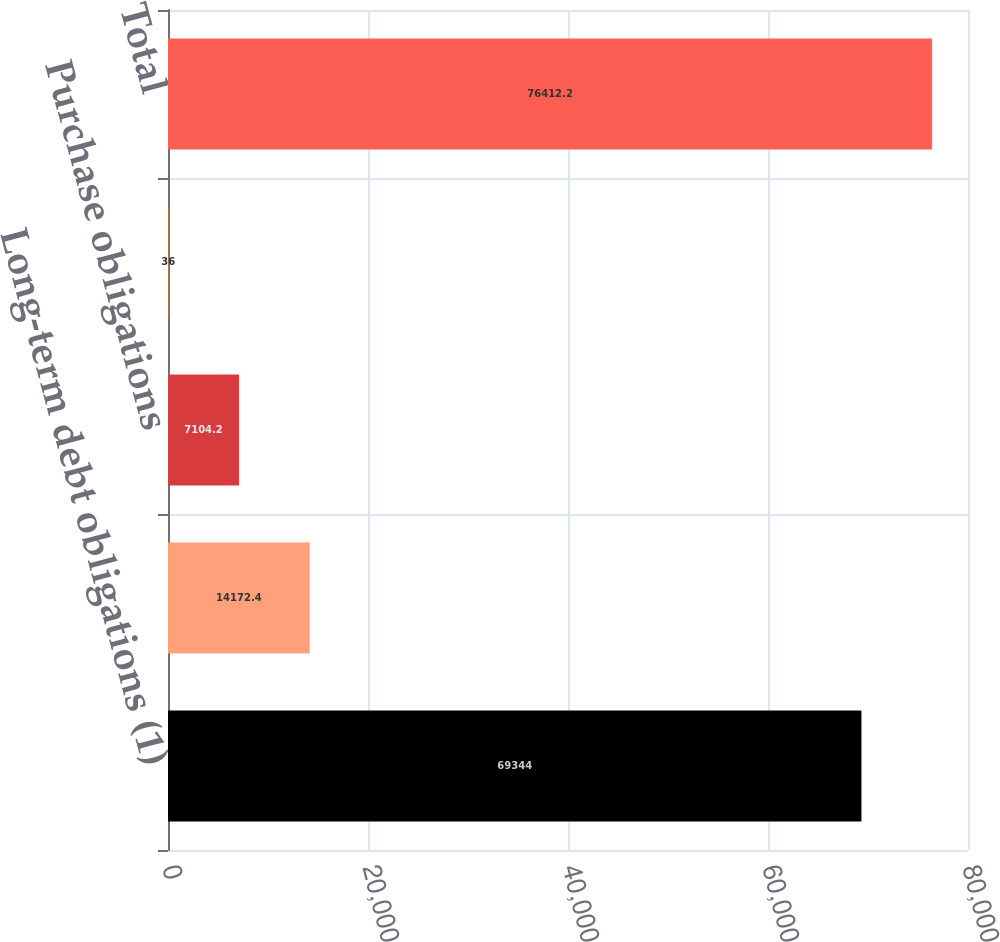<chart> <loc_0><loc_0><loc_500><loc_500><bar_chart><fcel>Long-term debt obligations (1)<fcel>Lease obligations<fcel>Purchase obligations<fcel>Other long-term liabilities<fcel>Total<nl><fcel>69344<fcel>14172.4<fcel>7104.2<fcel>36<fcel>76412.2<nl></chart> 